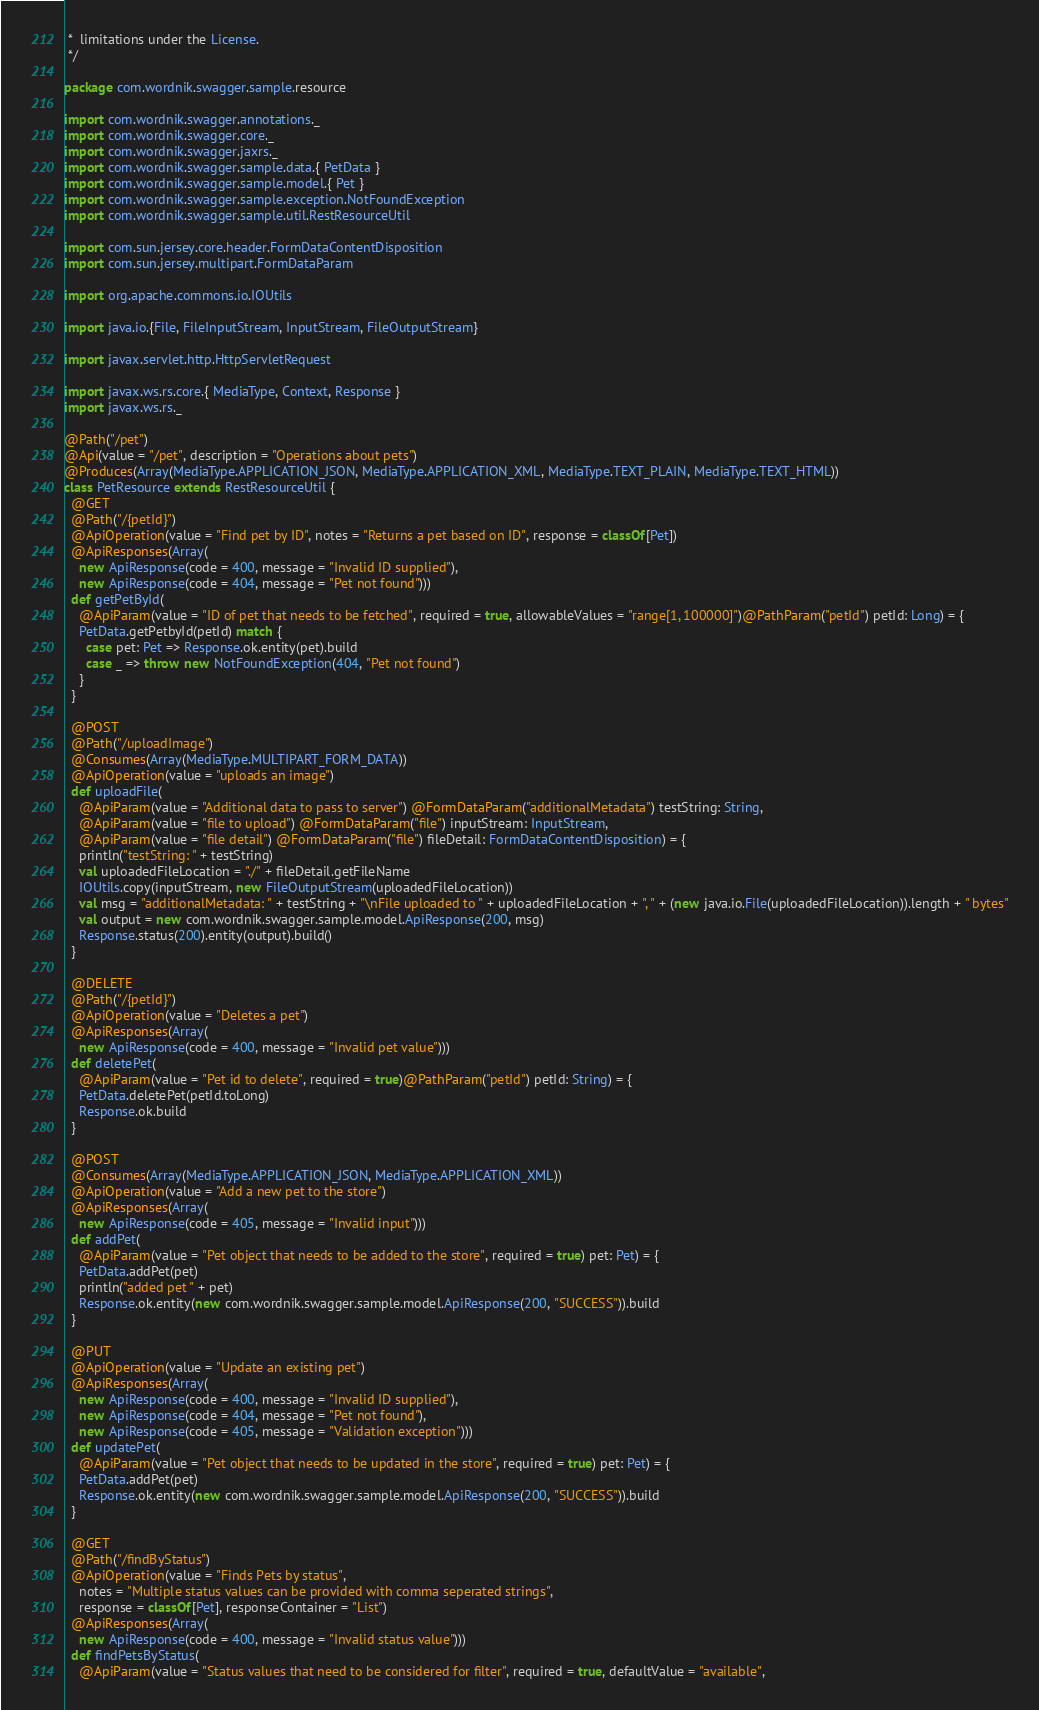<code> <loc_0><loc_0><loc_500><loc_500><_Scala_> *  limitations under the License.
 */

package com.wordnik.swagger.sample.resource

import com.wordnik.swagger.annotations._
import com.wordnik.swagger.core._
import com.wordnik.swagger.jaxrs._
import com.wordnik.swagger.sample.data.{ PetData }
import com.wordnik.swagger.sample.model.{ Pet }
import com.wordnik.swagger.sample.exception.NotFoundException
import com.wordnik.swagger.sample.util.RestResourceUtil

import com.sun.jersey.core.header.FormDataContentDisposition
import com.sun.jersey.multipart.FormDataParam

import org.apache.commons.io.IOUtils

import java.io.{File, FileInputStream, InputStream, FileOutputStream}

import javax.servlet.http.HttpServletRequest

import javax.ws.rs.core.{ MediaType, Context, Response }
import javax.ws.rs._

@Path("/pet")
@Api(value = "/pet", description = "Operations about pets")
@Produces(Array(MediaType.APPLICATION_JSON, MediaType.APPLICATION_XML, MediaType.TEXT_PLAIN, MediaType.TEXT_HTML))
class PetResource extends RestResourceUtil {
  @GET
  @Path("/{petId}")
  @ApiOperation(value = "Find pet by ID", notes = "Returns a pet based on ID", response = classOf[Pet])
  @ApiResponses(Array(
    new ApiResponse(code = 400, message = "Invalid ID supplied"),
    new ApiResponse(code = 404, message = "Pet not found")))
  def getPetById(
    @ApiParam(value = "ID of pet that needs to be fetched", required = true, allowableValues = "range[1, 100000]")@PathParam("petId") petId: Long) = {
    PetData.getPetbyId(petId) match {
      case pet: Pet => Response.ok.entity(pet).build
      case _ => throw new NotFoundException(404, "Pet not found")
    }
  }

  @POST
  @Path("/uploadImage")
  @Consumes(Array(MediaType.MULTIPART_FORM_DATA))
  @ApiOperation(value = "uploads an image")
  def uploadFile(
    @ApiParam(value = "Additional data to pass to server") @FormDataParam("additionalMetadata") testString: String,
    @ApiParam(value = "file to upload") @FormDataParam("file") inputStream: InputStream,
    @ApiParam(value = "file detail") @FormDataParam("file") fileDetail: FormDataContentDisposition) = {
    println("testString: " + testString)
    val uploadedFileLocation = "./" + fileDetail.getFileName
    IOUtils.copy(inputStream, new FileOutputStream(uploadedFileLocation))
    val msg = "additionalMetadata: " + testString + "\nFile uploaded to " + uploadedFileLocation + ", " + (new java.io.File(uploadedFileLocation)).length + " bytes"
    val output = new com.wordnik.swagger.sample.model.ApiResponse(200, msg)
    Response.status(200).entity(output).build()
  }

  @DELETE
  @Path("/{petId}")
  @ApiOperation(value = "Deletes a pet")
  @ApiResponses(Array(
    new ApiResponse(code = 400, message = "Invalid pet value")))
  def deletePet(
    @ApiParam(value = "Pet id to delete", required = true)@PathParam("petId") petId: String) = {
    PetData.deletePet(petId.toLong)
    Response.ok.build
  }

  @POST
  @Consumes(Array(MediaType.APPLICATION_JSON, MediaType.APPLICATION_XML))
  @ApiOperation(value = "Add a new pet to the store")
  @ApiResponses(Array(
    new ApiResponse(code = 405, message = "Invalid input")))
  def addPet(
    @ApiParam(value = "Pet object that needs to be added to the store", required = true) pet: Pet) = {
    PetData.addPet(pet)
    println("added pet " + pet)
    Response.ok.entity(new com.wordnik.swagger.sample.model.ApiResponse(200, "SUCCESS")).build
  }

  @PUT
  @ApiOperation(value = "Update an existing pet")
  @ApiResponses(Array(
    new ApiResponse(code = 400, message = "Invalid ID supplied"),
    new ApiResponse(code = 404, message = "Pet not found"),
    new ApiResponse(code = 405, message = "Validation exception")))
  def updatePet(
    @ApiParam(value = "Pet object that needs to be updated in the store", required = true) pet: Pet) = {
    PetData.addPet(pet)
    Response.ok.entity(new com.wordnik.swagger.sample.model.ApiResponse(200, "SUCCESS")).build
  }

  @GET
  @Path("/findByStatus")
  @ApiOperation(value = "Finds Pets by status",
    notes = "Multiple status values can be provided with comma seperated strings",
    response = classOf[Pet], responseContainer = "List")
  @ApiResponses(Array(
    new ApiResponse(code = 400, message = "Invalid status value")))
  def findPetsByStatus(
    @ApiParam(value = "Status values that need to be considered for filter", required = true, defaultValue = "available",</code> 